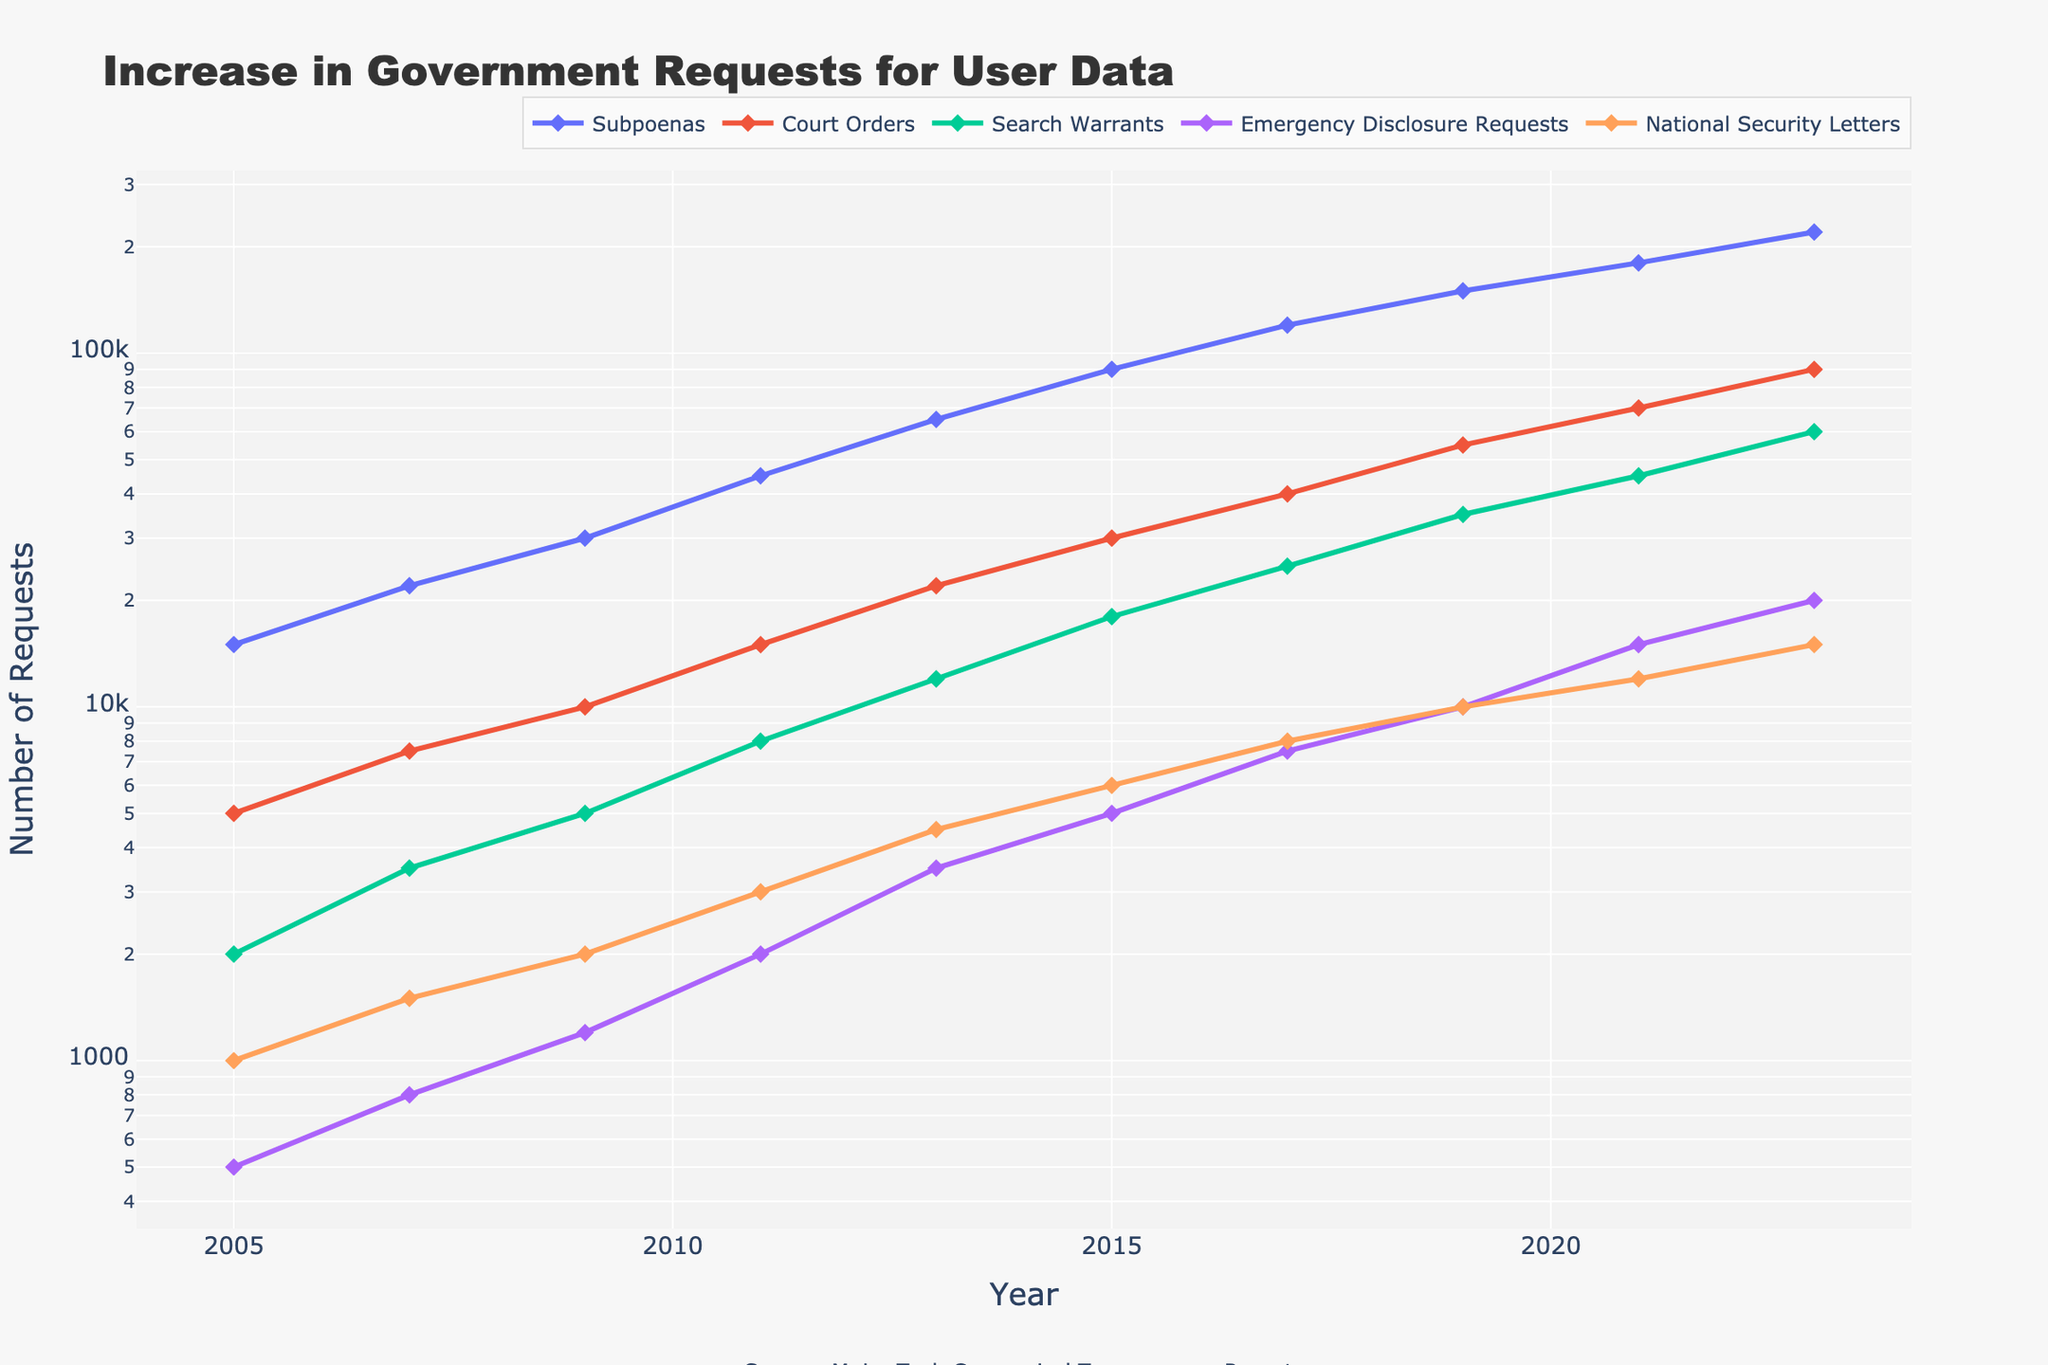What type of request saw the highest increase between 2005 and 2023? To find the highest increase, subtract the value in 2005 from the value in 2023 for each type of request. Subpoenas: 220,000 - 15,000 = 205,000; Court Orders: 90,000 - 5,000 = 85,000; Search Warrants: 60,000 - 2,000 = 58,000; Emergency Disclosure Requests: 20,000 - 500 = 19,500; National Security Letters: 15,000 - 1,000 = 14,000. Subpoenas have the highest increase.
Answer: Subpoenas Which type of request had the smallest relative increase from 2005 to 2023? Calculate the relative increase for each type by dividing the increase by the 2005 value. Subpoenas: (220,000 - 15,000) / 15,000 = 14.67; Court Orders: (90,000 - 5,000) / 5,000 = 17; Search Warrants: (60,000 - 2,000) / 2,000 = 29; Emergency Disclosure Requests: (20,000 - 500) / 500 = 39; National Security Letters: (15,000 - 1,000) / 1,000 = 14. Subpoenas have the smallest relative increase.
Answer: Subpoenas Which year showed the steepest increase in emergency disclosure requests compared to the previous year? Compare the increase in emergency disclosure requests between consecutive years. The steepest increase is between 2021 and 2023: 20,000 - 15,000 = 5,000. No other consecutive years have a greater increase than 5,000.
Answer: 2023 How did the number of search warrants and court orders compare in 2009? Look at the values for 2009: Search Warrants = 5,000 and Court Orders = 10,000. Search warrants are less than court orders in 2009.
Answer: Court orders are higher What is the overall trend in the number of national security letters between 2005 and 2023? Observe the values for national security letters over the years. They increase steadily from 1,000 in 2005 to 15,000 in 2023.
Answer: Increasing In which period did subpoenas see the largest rate of increase? Calculate the rate of increase for each period. The largest rate of increase for subpoenas happens between 2011 and 2013: (65,000 - 45,000) / 45,000 = 0.44.
Answer: 2011-2013 How many more subpoenas were there in 2023 compared to 2019? 220,000 (2023 value) - 150,000 (2019 value) = 70,000.
Answer: 70,000 Which type of request remained consistently the lowest throughout 2005 to 2023? Compare the values of each request type across all years. Emergency Disclosure Requests are the lowest throughout the entire period.
Answer: Emergency Disclosure Requests When did search warrants first exceed 10,000 requests? Look at the values of search warrants over the years to find when it first exceeds 10,000. It first exceeds 10,000 in 2015 (18,000).
Answer: 2015 